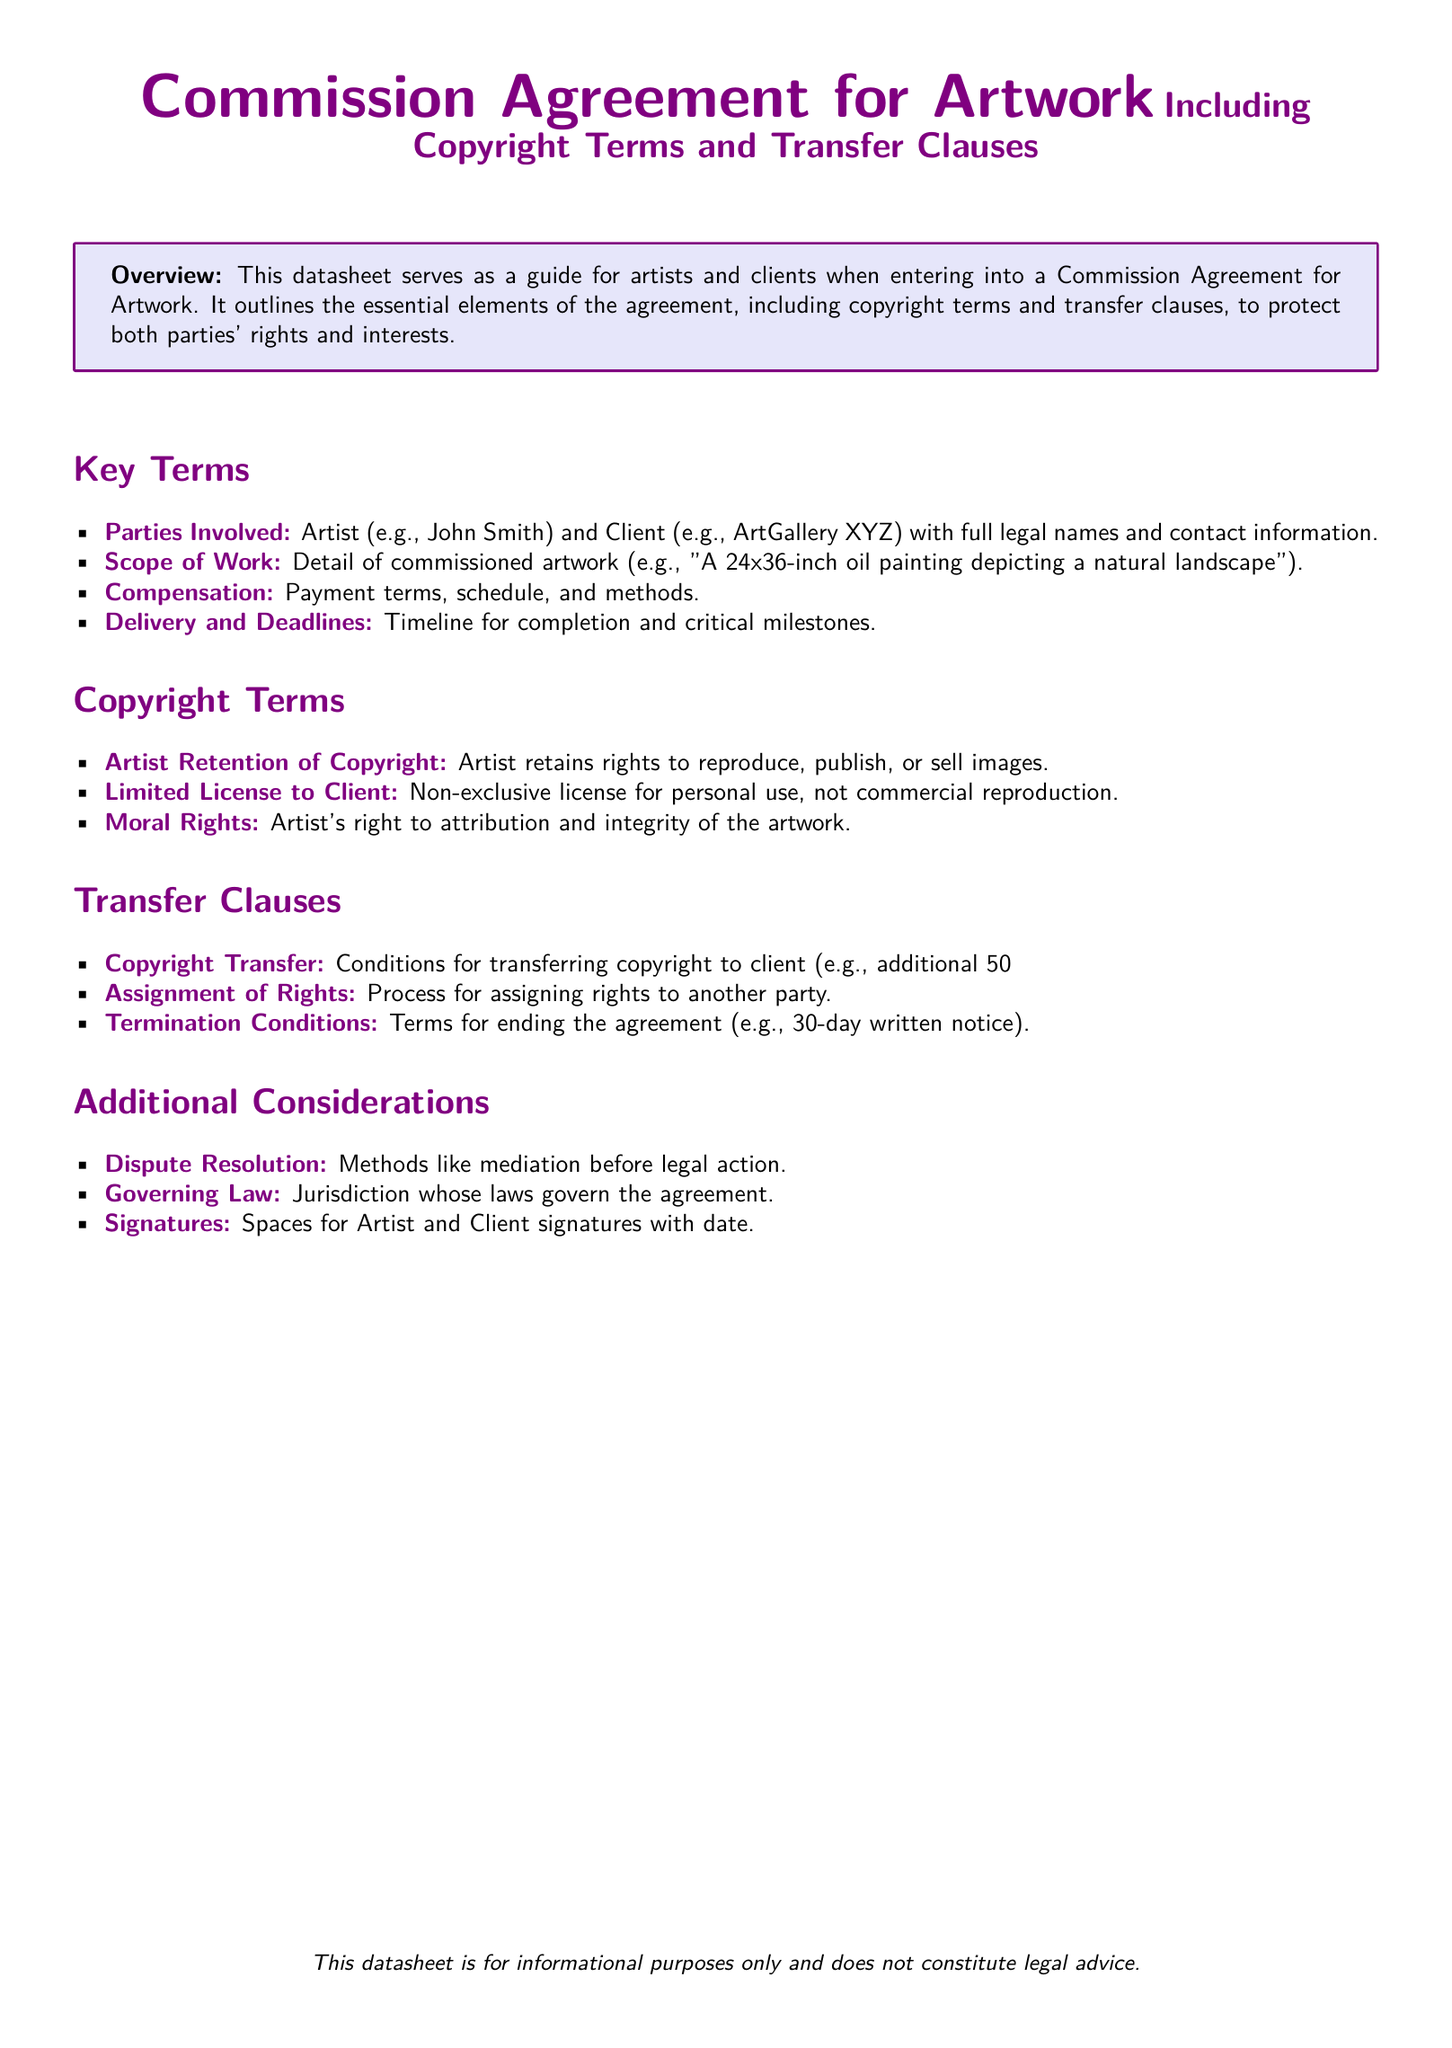What is the main purpose of the datasheet? The main purpose of the datasheet is to serve as a guide for artists and clients when entering into a Commission Agreement for Artwork.
Answer: Guide for artists and clients Who are the parties involved in the commission agreement? The parties involved in the commission agreement are the Artist and Client.
Answer: Artist and Client What is an example of the scope of work mentioned? The scope of work includes details of commissioned artwork such as "A 24x36-inch oil painting depicting a natural landscape."
Answer: A 24x36-inch oil painting What does the artist retain under copyright terms? Under copyright terms, the artist retains rights to reproduce, publish, or sell images of the artwork.
Answer: Rights to reproduce, publish, or sell images What is required for copyright transfer to the client? Conditions for transferring copyright to the client include an additional 50% fee.
Answer: Additional 50% fee What is the method mentioned for dispute resolution? The document mentions mediation as a method for dispute resolution before legal action.
Answer: Mediation What is the governing law in the agreement? The governing law refers to the jurisdiction whose laws govern the agreement.
Answer: Jurisdiction laws How long is the notice period for termination of the agreement? The termination conditions state a 30-day written notice is required for ending the agreement.
Answer: 30-day written notice What rights does the artist have regarding moral rights? The moral rights include the artist's right to attribution and integrity of the artwork.
Answer: Right to attribution and integrity 